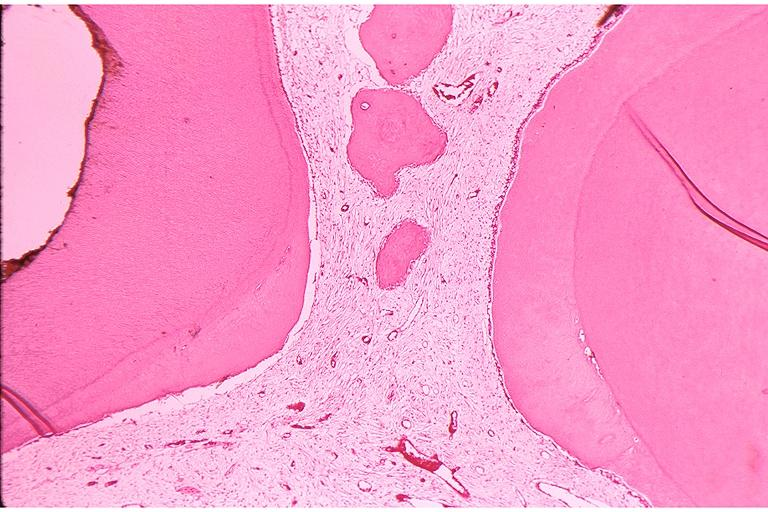where is this?
Answer the question using a single word or phrase. Oral 